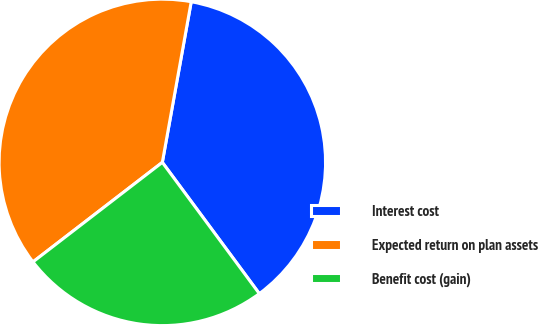Convert chart. <chart><loc_0><loc_0><loc_500><loc_500><pie_chart><fcel>Interest cost<fcel>Expected return on plan assets<fcel>Benefit cost (gain)<nl><fcel>37.04%<fcel>38.27%<fcel>24.69%<nl></chart> 